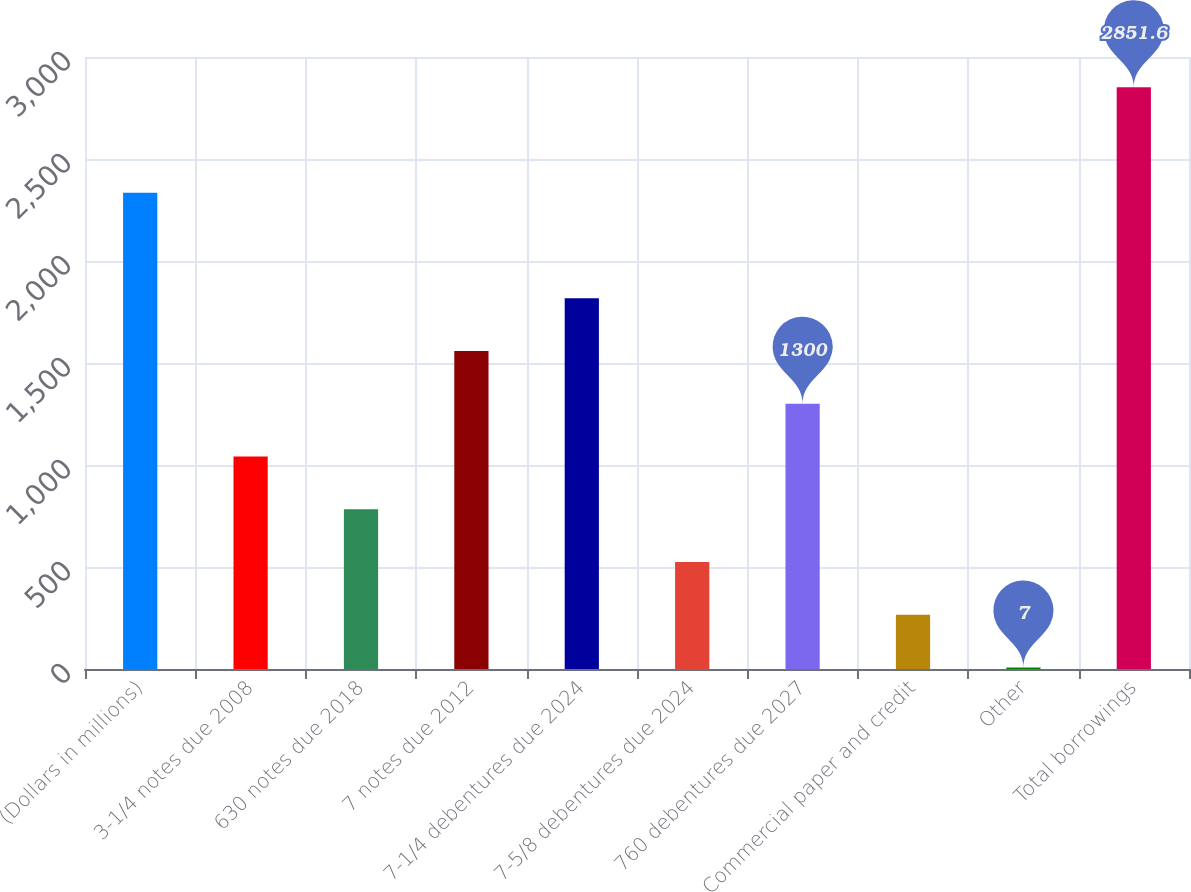Convert chart to OTSL. <chart><loc_0><loc_0><loc_500><loc_500><bar_chart><fcel>(Dollars in millions)<fcel>3-1/4 notes due 2008<fcel>630 notes due 2018<fcel>7 notes due 2012<fcel>7-1/4 debentures due 2024<fcel>7-5/8 debentures due 2024<fcel>760 debentures due 2027<fcel>Commercial paper and credit<fcel>Other<fcel>Total borrowings<nl><fcel>2334.4<fcel>1041.4<fcel>782.8<fcel>1558.6<fcel>1817.2<fcel>524.2<fcel>1300<fcel>265.6<fcel>7<fcel>2851.6<nl></chart> 